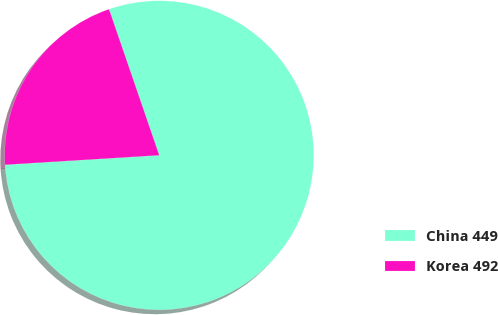Convert chart. <chart><loc_0><loc_0><loc_500><loc_500><pie_chart><fcel>China 449<fcel>Korea 492<nl><fcel>79.29%<fcel>20.71%<nl></chart> 